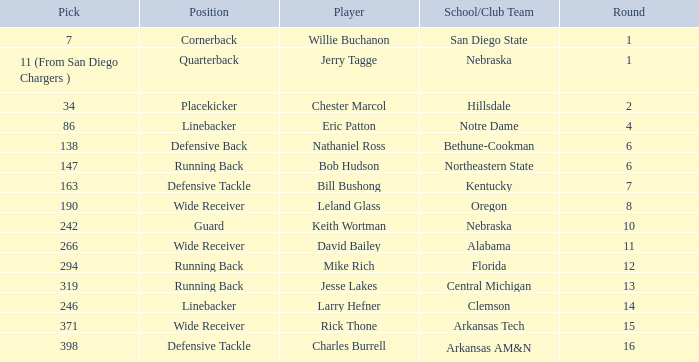Which round has a position that is cornerback? 1.0. 